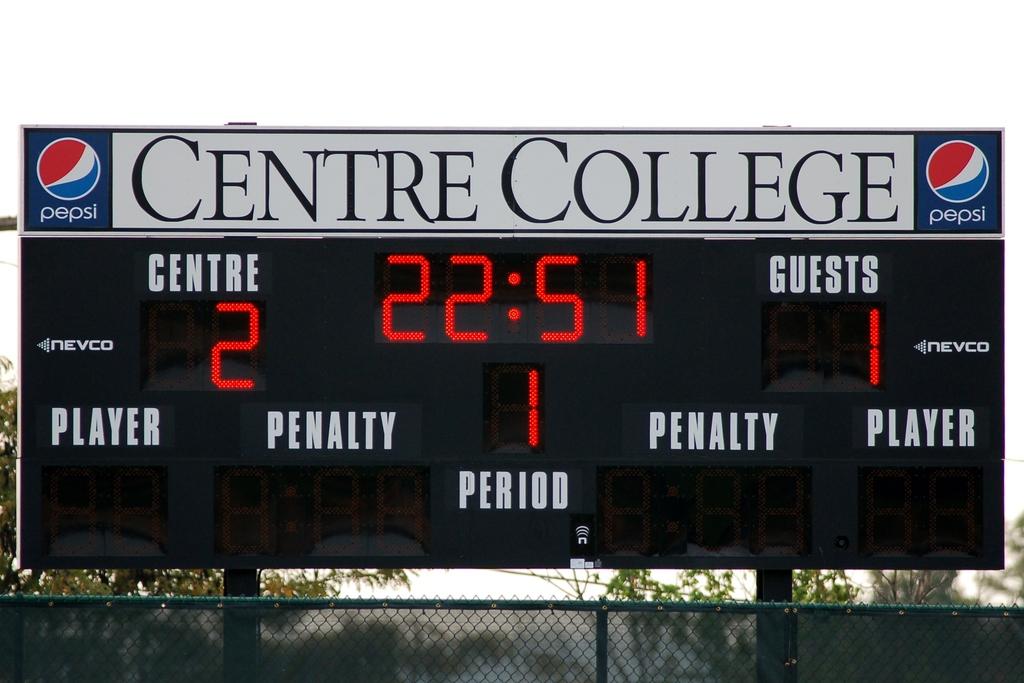What time is it?
Your answer should be compact. 22:51. 